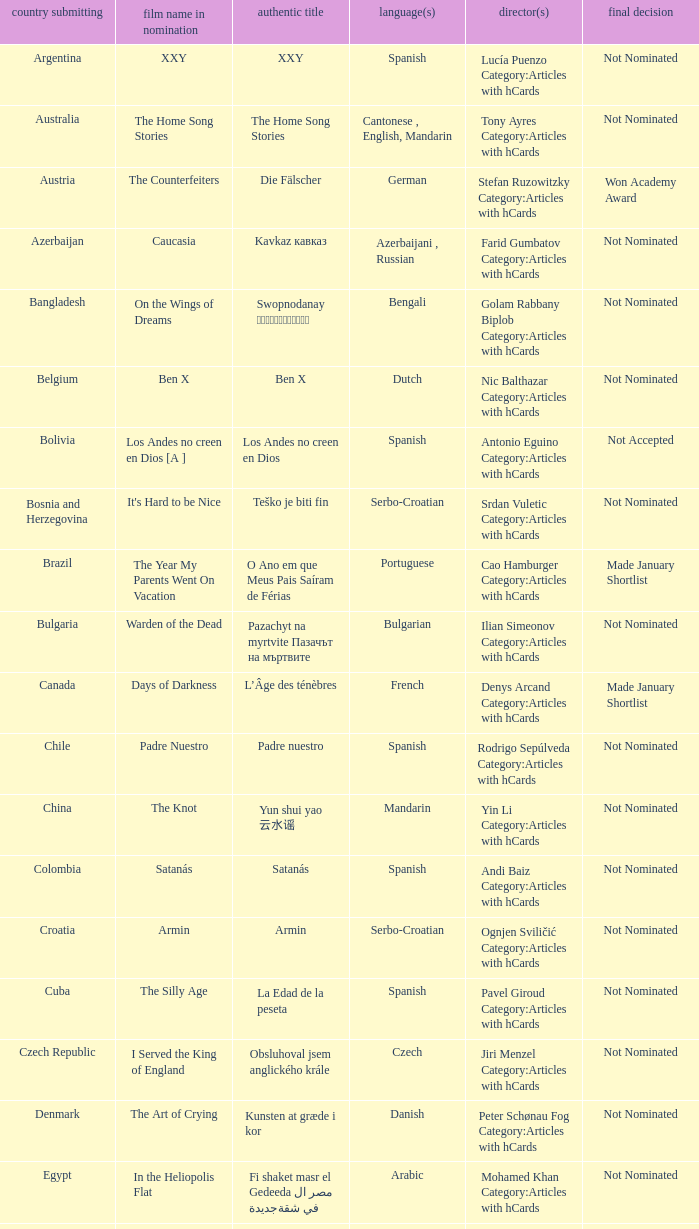What was the title of the movie from lebanon? Caramel. 